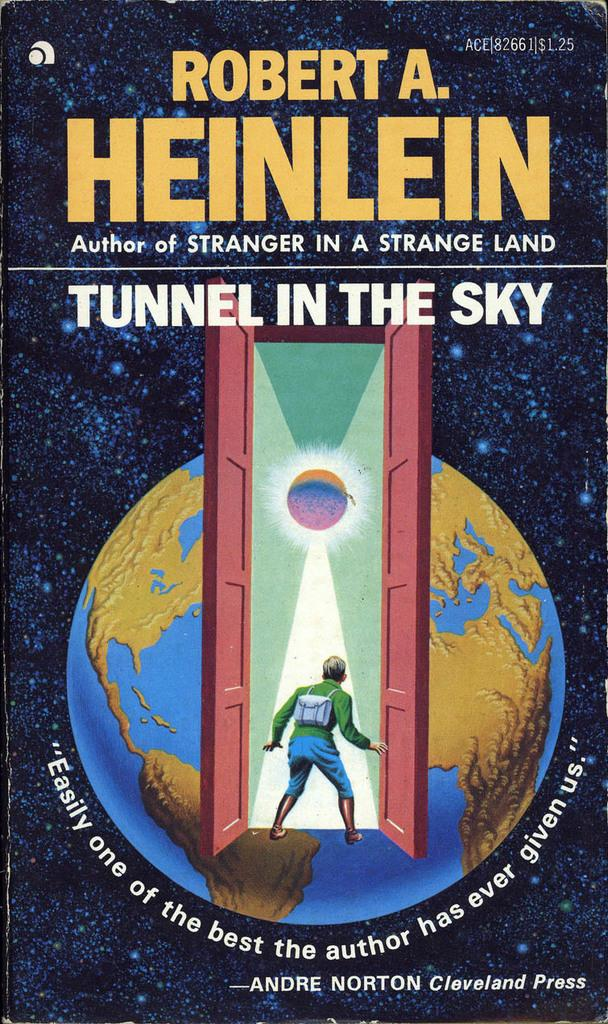<image>
Present a compact description of the photo's key features. A book cover with a globe and a title of Tunnel in The Sky. 